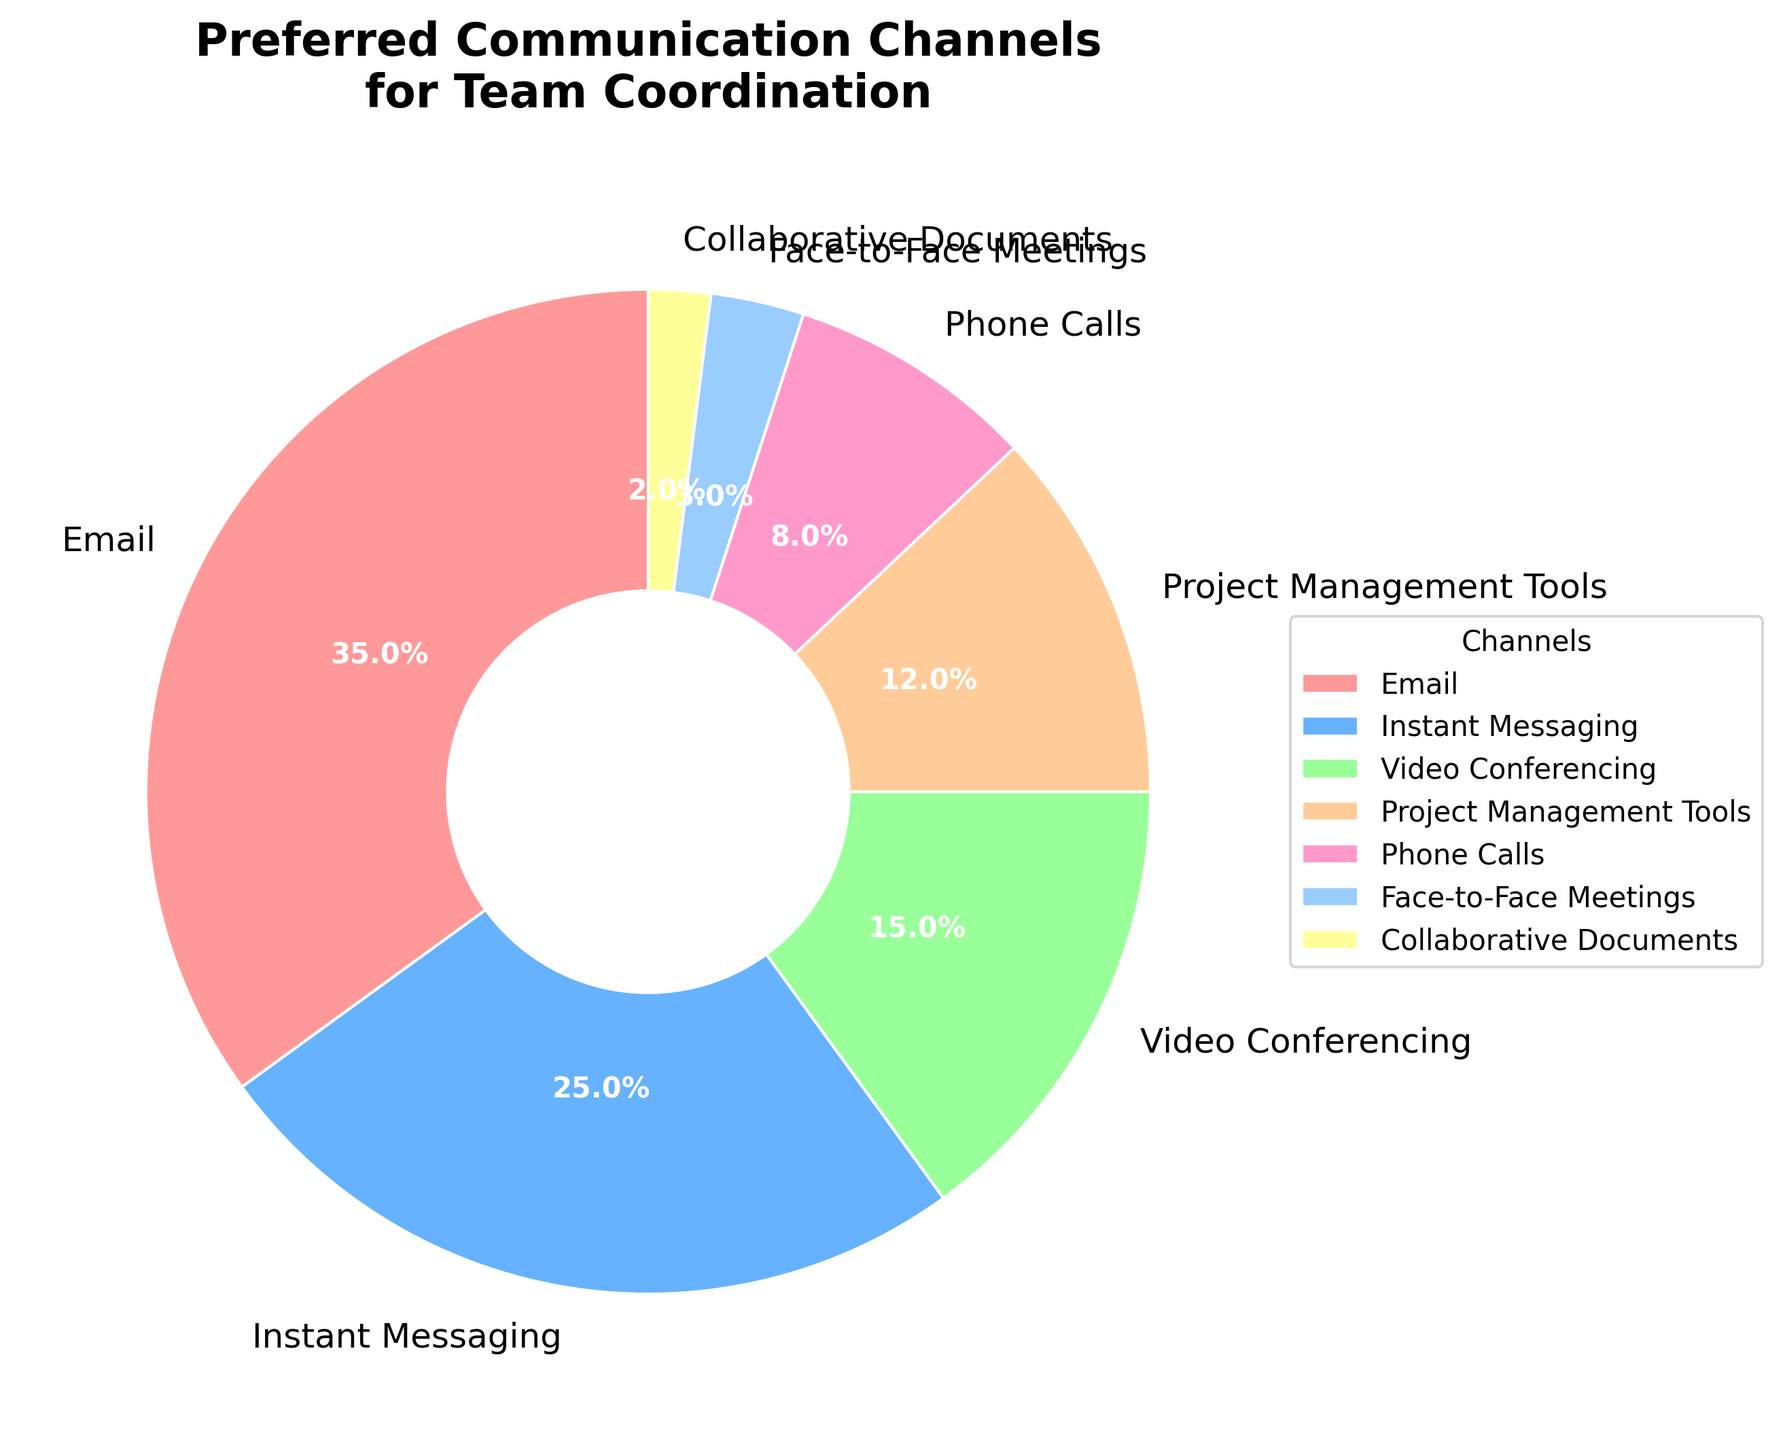Which communication channel is most preferred for team coordination? The largest slice of the pie chart represents the preferred communication channel, which is Email at 35%.
Answer: Email Which communication channels have a percentage lower than 10%? By observing the slices with percentages less than 10%, we see Phone Calls (8%), Face-to-Face Meetings (3%), and Collaborative Documents (2%).
Answer: Phone Calls, Face-to-Face Meetings, Collaborative Documents How much higher is the preference for Instant Messaging compared to Phone Calls? Instant Messaging has a percentage of 25% and Phone Calls have 8%. The difference is calculated as 25% - 8%.
Answer: 17% What is the combined percentage for Project Management Tools and Face-to-Face Meetings? Project Management Tools have 12% and Face-to-Face Meetings have 3%. Adding these together gives 12% + 3% = 15%.
Answer: 15% Which channel has a higher percentage: Video Conferencing or Phone Calls? Video Conferencing has 15% and Phone Calls have 8%. Comparing these, Video Conferencing is higher.
Answer: Video Conferencing Are there more communication channels preferred at 15% and above or below 15%? Channels at 15% and above are Email (35%), Instant Messaging (25%), and Video Conferencing (15%). Channels below 15% are Project Management Tools (12%), Phone Calls (8%), Face-to-Face Meetings (3%), and Collaborative Documents (2%). There are 3 channels at or above 15% and 4 channels below 15%.
Answer: Below 15% What percentage of team coordination is handled by Email and Instant Messaging combined? Email is 35% and Instant Messaging is 25%. Adding these gives 35% + 25% = 60%.
Answer: 60% What is the average percentage of preference among all communication channels? The percentages are 35, 25, 15, 12, 8, 3, and 2. The total sum is 35+25+15+12+8+3+2=100. There are 7 channels, so the average is 100/7.
Answer: Approximately 14.3% Which communication channel uses green color for its slice on the pie chart? By referring to the custom color mapping, Instant Messaging uses the green color in the pie chart.
Answer: Instant Messaging 